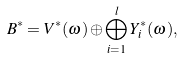<formula> <loc_0><loc_0><loc_500><loc_500>\ B ^ { * } = V ^ { * } ( \omega ) \oplus \bigoplus _ { i = 1 } ^ { l } Y _ { i } ^ { * } ( \omega ) ,</formula> 